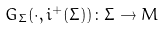Convert formula to latex. <formula><loc_0><loc_0><loc_500><loc_500>G _ { \Sigma } ( \cdot , i ^ { + } ( \Sigma ) ) \colon \Sigma \to M</formula> 